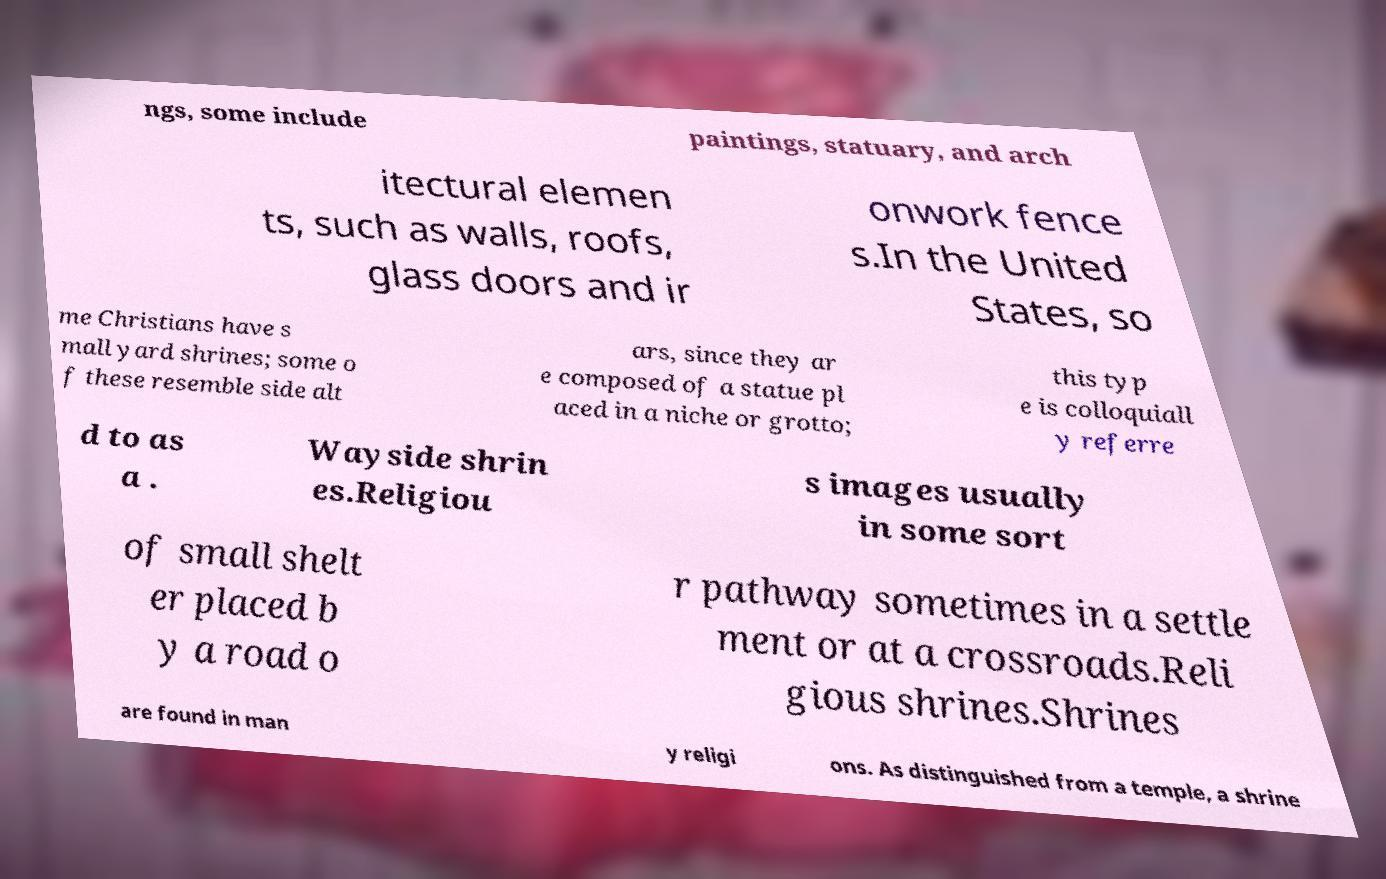Please identify and transcribe the text found in this image. ngs, some include paintings, statuary, and arch itectural elemen ts, such as walls, roofs, glass doors and ir onwork fence s.In the United States, so me Christians have s mall yard shrines; some o f these resemble side alt ars, since they ar e composed of a statue pl aced in a niche or grotto; this typ e is colloquiall y referre d to as a . Wayside shrin es.Religiou s images usually in some sort of small shelt er placed b y a road o r pathway sometimes in a settle ment or at a crossroads.Reli gious shrines.Shrines are found in man y religi ons. As distinguished from a temple, a shrine 